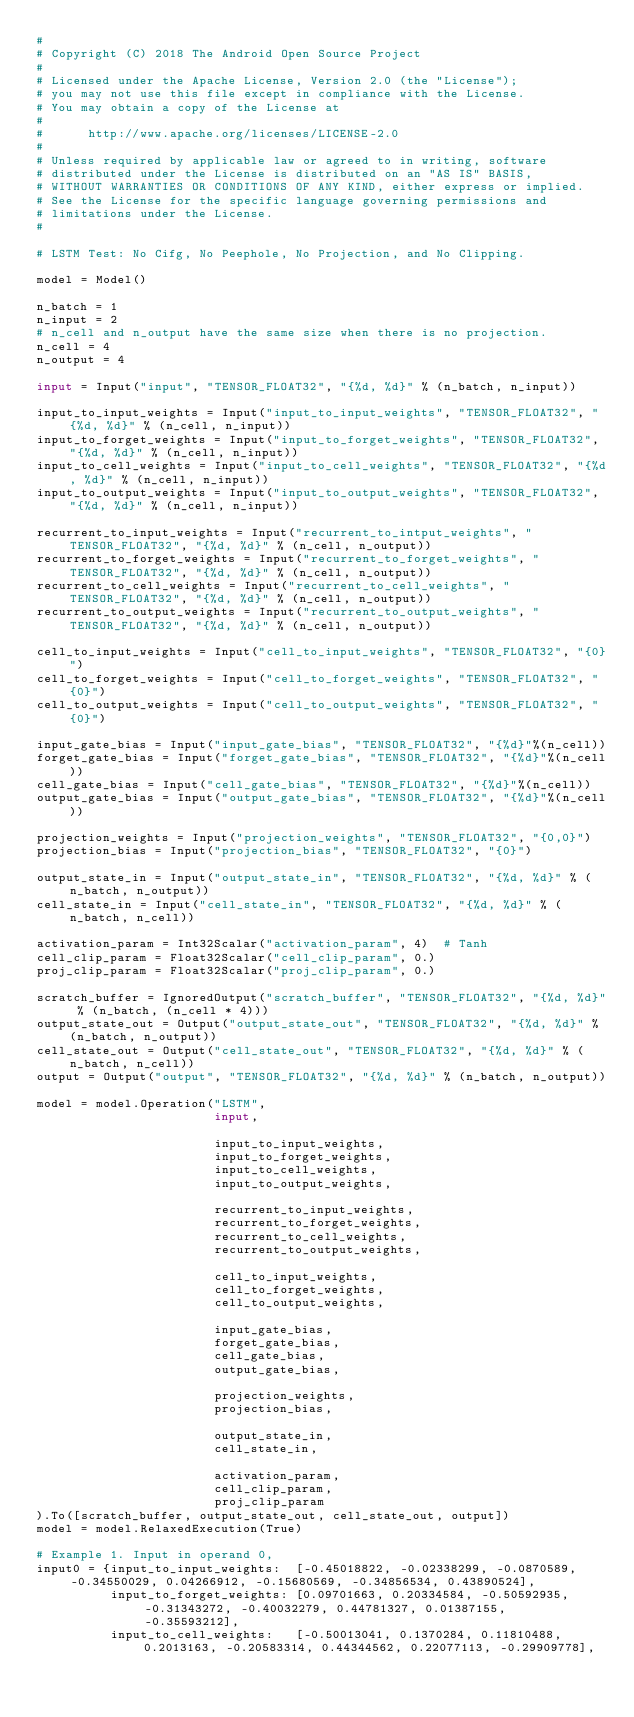<code> <loc_0><loc_0><loc_500><loc_500><_Python_>#
# Copyright (C) 2018 The Android Open Source Project
#
# Licensed under the Apache License, Version 2.0 (the "License");
# you may not use this file except in compliance with the License.
# You may obtain a copy of the License at
#
#      http://www.apache.org/licenses/LICENSE-2.0
#
# Unless required by applicable law or agreed to in writing, software
# distributed under the License is distributed on an "AS IS" BASIS,
# WITHOUT WARRANTIES OR CONDITIONS OF ANY KIND, either express or implied.
# See the License for the specific language governing permissions and
# limitations under the License.
#

# LSTM Test: No Cifg, No Peephole, No Projection, and No Clipping.

model = Model()

n_batch = 1
n_input = 2
# n_cell and n_output have the same size when there is no projection.
n_cell = 4
n_output = 4

input = Input("input", "TENSOR_FLOAT32", "{%d, %d}" % (n_batch, n_input))

input_to_input_weights = Input("input_to_input_weights", "TENSOR_FLOAT32", "{%d, %d}" % (n_cell, n_input))
input_to_forget_weights = Input("input_to_forget_weights", "TENSOR_FLOAT32", "{%d, %d}" % (n_cell, n_input))
input_to_cell_weights = Input("input_to_cell_weights", "TENSOR_FLOAT32", "{%d, %d}" % (n_cell, n_input))
input_to_output_weights = Input("input_to_output_weights", "TENSOR_FLOAT32", "{%d, %d}" % (n_cell, n_input))

recurrent_to_input_weights = Input("recurrent_to_intput_weights", "TENSOR_FLOAT32", "{%d, %d}" % (n_cell, n_output))
recurrent_to_forget_weights = Input("recurrent_to_forget_weights", "TENSOR_FLOAT32", "{%d, %d}" % (n_cell, n_output))
recurrent_to_cell_weights = Input("recurrent_to_cell_weights", "TENSOR_FLOAT32", "{%d, %d}" % (n_cell, n_output))
recurrent_to_output_weights = Input("recurrent_to_output_weights", "TENSOR_FLOAT32", "{%d, %d}" % (n_cell, n_output))

cell_to_input_weights = Input("cell_to_input_weights", "TENSOR_FLOAT32", "{0}")
cell_to_forget_weights = Input("cell_to_forget_weights", "TENSOR_FLOAT32", "{0}")
cell_to_output_weights = Input("cell_to_output_weights", "TENSOR_FLOAT32", "{0}")

input_gate_bias = Input("input_gate_bias", "TENSOR_FLOAT32", "{%d}"%(n_cell))
forget_gate_bias = Input("forget_gate_bias", "TENSOR_FLOAT32", "{%d}"%(n_cell))
cell_gate_bias = Input("cell_gate_bias", "TENSOR_FLOAT32", "{%d}"%(n_cell))
output_gate_bias = Input("output_gate_bias", "TENSOR_FLOAT32", "{%d}"%(n_cell))

projection_weights = Input("projection_weights", "TENSOR_FLOAT32", "{0,0}")
projection_bias = Input("projection_bias", "TENSOR_FLOAT32", "{0}")

output_state_in = Input("output_state_in", "TENSOR_FLOAT32", "{%d, %d}" % (n_batch, n_output))
cell_state_in = Input("cell_state_in", "TENSOR_FLOAT32", "{%d, %d}" % (n_batch, n_cell))

activation_param = Int32Scalar("activation_param", 4)  # Tanh
cell_clip_param = Float32Scalar("cell_clip_param", 0.)
proj_clip_param = Float32Scalar("proj_clip_param", 0.)

scratch_buffer = IgnoredOutput("scratch_buffer", "TENSOR_FLOAT32", "{%d, %d}" % (n_batch, (n_cell * 4)))
output_state_out = Output("output_state_out", "TENSOR_FLOAT32", "{%d, %d}" % (n_batch, n_output))
cell_state_out = Output("cell_state_out", "TENSOR_FLOAT32", "{%d, %d}" % (n_batch, n_cell))
output = Output("output", "TENSOR_FLOAT32", "{%d, %d}" % (n_batch, n_output))

model = model.Operation("LSTM",
                        input,

                        input_to_input_weights,
                        input_to_forget_weights,
                        input_to_cell_weights,
                        input_to_output_weights,

                        recurrent_to_input_weights,
                        recurrent_to_forget_weights,
                        recurrent_to_cell_weights,
                        recurrent_to_output_weights,

                        cell_to_input_weights,
                        cell_to_forget_weights,
                        cell_to_output_weights,

                        input_gate_bias,
                        forget_gate_bias,
                        cell_gate_bias,
                        output_gate_bias,

                        projection_weights,
                        projection_bias,

                        output_state_in,
                        cell_state_in,

                        activation_param,
                        cell_clip_param,
                        proj_clip_param
).To([scratch_buffer, output_state_out, cell_state_out, output])
model = model.RelaxedExecution(True)

# Example 1. Input in operand 0,
input0 = {input_to_input_weights:  [-0.45018822, -0.02338299, -0.0870589, -0.34550029, 0.04266912, -0.15680569, -0.34856534, 0.43890524],
          input_to_forget_weights: [0.09701663, 0.20334584, -0.50592935, -0.31343272, -0.40032279, 0.44781327, 0.01387155, -0.35593212],
          input_to_cell_weights:   [-0.50013041, 0.1370284, 0.11810488, 0.2013163, -0.20583314, 0.44344562, 0.22077113, -0.29909778],</code> 